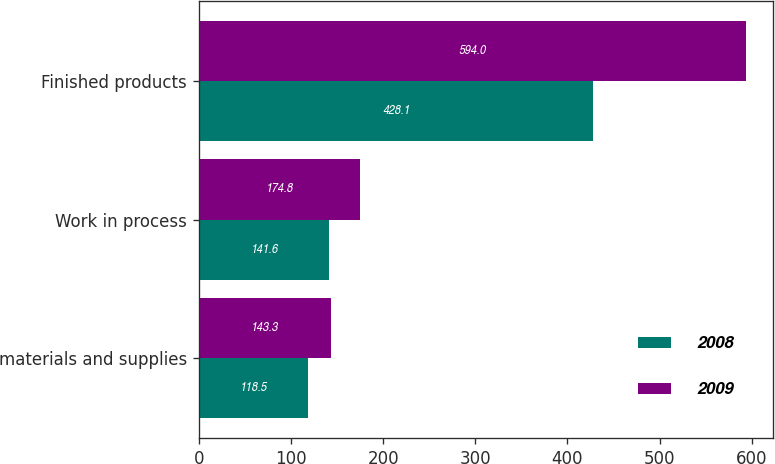Convert chart to OTSL. <chart><loc_0><loc_0><loc_500><loc_500><stacked_bar_chart><ecel><fcel>materials and supplies<fcel>Work in process<fcel>Finished products<nl><fcel>2008<fcel>118.5<fcel>141.6<fcel>428.1<nl><fcel>2009<fcel>143.3<fcel>174.8<fcel>594<nl></chart> 